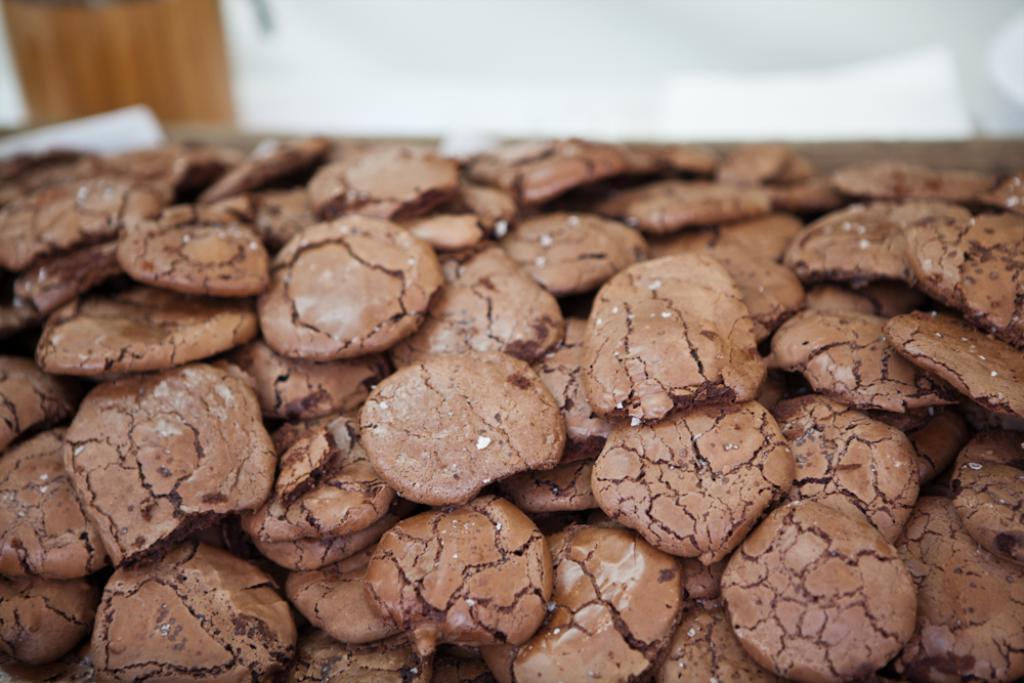In one or two sentences, can you explain what this image depicts? In this picture we can see cookies on a surface and in the background it is blurry. 